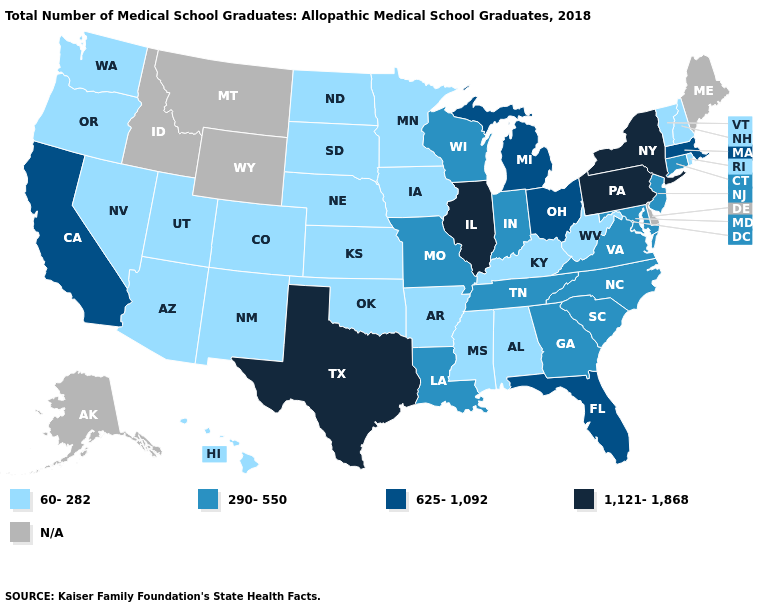What is the highest value in the West ?
Write a very short answer. 625-1,092. Name the states that have a value in the range 1,121-1,868?
Answer briefly. Illinois, New York, Pennsylvania, Texas. Name the states that have a value in the range 290-550?
Be succinct. Connecticut, Georgia, Indiana, Louisiana, Maryland, Missouri, New Jersey, North Carolina, South Carolina, Tennessee, Virginia, Wisconsin. What is the value of Louisiana?
Short answer required. 290-550. Which states have the lowest value in the USA?
Quick response, please. Alabama, Arizona, Arkansas, Colorado, Hawaii, Iowa, Kansas, Kentucky, Minnesota, Mississippi, Nebraska, Nevada, New Hampshire, New Mexico, North Dakota, Oklahoma, Oregon, Rhode Island, South Dakota, Utah, Vermont, Washington, West Virginia. Name the states that have a value in the range N/A?
Write a very short answer. Alaska, Delaware, Idaho, Maine, Montana, Wyoming. Which states have the lowest value in the USA?
Short answer required. Alabama, Arizona, Arkansas, Colorado, Hawaii, Iowa, Kansas, Kentucky, Minnesota, Mississippi, Nebraska, Nevada, New Hampshire, New Mexico, North Dakota, Oklahoma, Oregon, Rhode Island, South Dakota, Utah, Vermont, Washington, West Virginia. Name the states that have a value in the range 60-282?
Short answer required. Alabama, Arizona, Arkansas, Colorado, Hawaii, Iowa, Kansas, Kentucky, Minnesota, Mississippi, Nebraska, Nevada, New Hampshire, New Mexico, North Dakota, Oklahoma, Oregon, Rhode Island, South Dakota, Utah, Vermont, Washington, West Virginia. Which states have the lowest value in the USA?
Answer briefly. Alabama, Arizona, Arkansas, Colorado, Hawaii, Iowa, Kansas, Kentucky, Minnesota, Mississippi, Nebraska, Nevada, New Hampshire, New Mexico, North Dakota, Oklahoma, Oregon, Rhode Island, South Dakota, Utah, Vermont, Washington, West Virginia. Among the states that border Kansas , does Oklahoma have the highest value?
Be succinct. No. What is the lowest value in the South?
Give a very brief answer. 60-282. What is the value of Kansas?
Answer briefly. 60-282. 